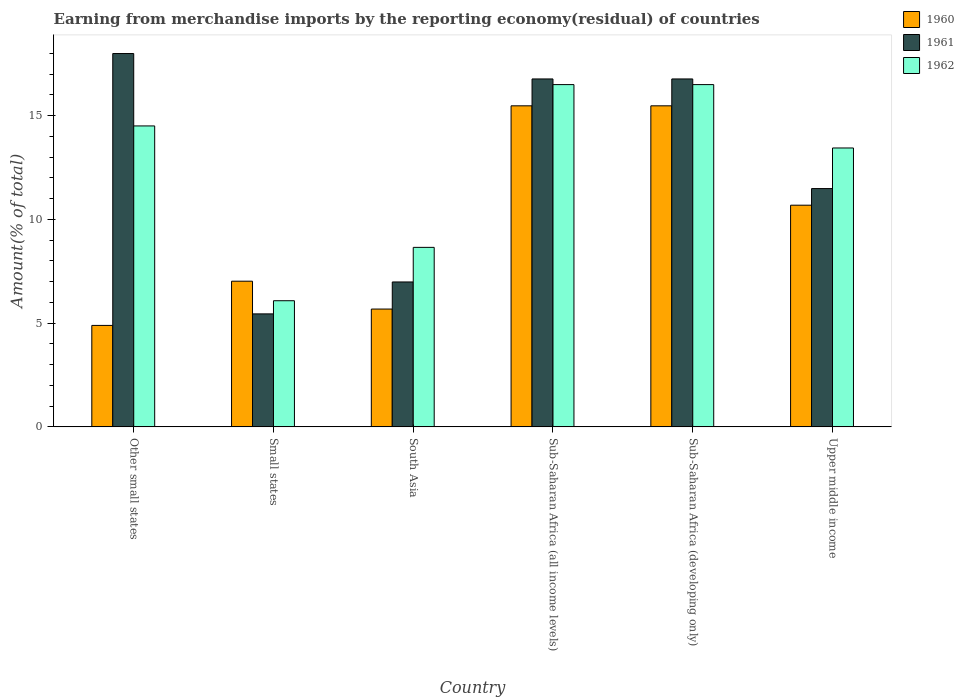How many different coloured bars are there?
Ensure brevity in your answer.  3. How many groups of bars are there?
Your answer should be very brief. 6. Are the number of bars per tick equal to the number of legend labels?
Give a very brief answer. Yes. Are the number of bars on each tick of the X-axis equal?
Your answer should be compact. Yes. What is the label of the 5th group of bars from the left?
Offer a terse response. Sub-Saharan Africa (developing only). In how many cases, is the number of bars for a given country not equal to the number of legend labels?
Give a very brief answer. 0. What is the percentage of amount earned from merchandise imports in 1960 in Other small states?
Offer a very short reply. 4.89. Across all countries, what is the maximum percentage of amount earned from merchandise imports in 1960?
Provide a short and direct response. 15.47. Across all countries, what is the minimum percentage of amount earned from merchandise imports in 1960?
Make the answer very short. 4.89. In which country was the percentage of amount earned from merchandise imports in 1960 maximum?
Keep it short and to the point. Sub-Saharan Africa (all income levels). In which country was the percentage of amount earned from merchandise imports in 1961 minimum?
Your answer should be compact. Small states. What is the total percentage of amount earned from merchandise imports in 1961 in the graph?
Provide a succinct answer. 75.45. What is the difference between the percentage of amount earned from merchandise imports in 1961 in South Asia and that in Upper middle income?
Your response must be concise. -4.5. What is the difference between the percentage of amount earned from merchandise imports in 1960 in Upper middle income and the percentage of amount earned from merchandise imports in 1962 in South Asia?
Offer a terse response. 2.03. What is the average percentage of amount earned from merchandise imports in 1961 per country?
Your answer should be very brief. 12.57. What is the difference between the percentage of amount earned from merchandise imports of/in 1960 and percentage of amount earned from merchandise imports of/in 1962 in Small states?
Make the answer very short. 0.94. In how many countries, is the percentage of amount earned from merchandise imports in 1961 greater than 6 %?
Keep it short and to the point. 5. What is the ratio of the percentage of amount earned from merchandise imports in 1960 in Other small states to that in South Asia?
Offer a very short reply. 0.86. Is the percentage of amount earned from merchandise imports in 1960 in South Asia less than that in Upper middle income?
Keep it short and to the point. Yes. Is the difference between the percentage of amount earned from merchandise imports in 1960 in Small states and Sub-Saharan Africa (developing only) greater than the difference between the percentage of amount earned from merchandise imports in 1962 in Small states and Sub-Saharan Africa (developing only)?
Make the answer very short. Yes. What is the difference between the highest and the second highest percentage of amount earned from merchandise imports in 1962?
Provide a succinct answer. 1.99. What is the difference between the highest and the lowest percentage of amount earned from merchandise imports in 1962?
Give a very brief answer. 10.42. In how many countries, is the percentage of amount earned from merchandise imports in 1960 greater than the average percentage of amount earned from merchandise imports in 1960 taken over all countries?
Keep it short and to the point. 3. What does the 2nd bar from the left in Other small states represents?
Give a very brief answer. 1961. What does the 3rd bar from the right in Other small states represents?
Ensure brevity in your answer.  1960. How many bars are there?
Offer a very short reply. 18. How many countries are there in the graph?
Your answer should be very brief. 6. Does the graph contain grids?
Provide a succinct answer. No. How are the legend labels stacked?
Your response must be concise. Vertical. What is the title of the graph?
Give a very brief answer. Earning from merchandise imports by the reporting economy(residual) of countries. Does "1979" appear as one of the legend labels in the graph?
Your response must be concise. No. What is the label or title of the X-axis?
Your answer should be compact. Country. What is the label or title of the Y-axis?
Make the answer very short. Amount(% of total). What is the Amount(% of total) in 1960 in Other small states?
Ensure brevity in your answer.  4.89. What is the Amount(% of total) of 1961 in Other small states?
Provide a short and direct response. 17.99. What is the Amount(% of total) of 1962 in Other small states?
Provide a short and direct response. 14.51. What is the Amount(% of total) in 1960 in Small states?
Offer a terse response. 7.02. What is the Amount(% of total) of 1961 in Small states?
Offer a very short reply. 5.45. What is the Amount(% of total) in 1962 in Small states?
Keep it short and to the point. 6.08. What is the Amount(% of total) in 1960 in South Asia?
Make the answer very short. 5.68. What is the Amount(% of total) of 1961 in South Asia?
Offer a terse response. 6.98. What is the Amount(% of total) in 1962 in South Asia?
Your answer should be compact. 8.65. What is the Amount(% of total) in 1960 in Sub-Saharan Africa (all income levels)?
Offer a very short reply. 15.47. What is the Amount(% of total) of 1961 in Sub-Saharan Africa (all income levels)?
Provide a succinct answer. 16.77. What is the Amount(% of total) in 1962 in Sub-Saharan Africa (all income levels)?
Provide a succinct answer. 16.5. What is the Amount(% of total) of 1960 in Sub-Saharan Africa (developing only)?
Offer a terse response. 15.47. What is the Amount(% of total) of 1961 in Sub-Saharan Africa (developing only)?
Keep it short and to the point. 16.77. What is the Amount(% of total) in 1962 in Sub-Saharan Africa (developing only)?
Your answer should be compact. 16.5. What is the Amount(% of total) in 1960 in Upper middle income?
Ensure brevity in your answer.  10.68. What is the Amount(% of total) of 1961 in Upper middle income?
Ensure brevity in your answer.  11.49. What is the Amount(% of total) of 1962 in Upper middle income?
Your response must be concise. 13.44. Across all countries, what is the maximum Amount(% of total) in 1960?
Make the answer very short. 15.47. Across all countries, what is the maximum Amount(% of total) in 1961?
Your answer should be compact. 17.99. Across all countries, what is the maximum Amount(% of total) of 1962?
Offer a terse response. 16.5. Across all countries, what is the minimum Amount(% of total) of 1960?
Provide a succinct answer. 4.89. Across all countries, what is the minimum Amount(% of total) in 1961?
Your answer should be compact. 5.45. Across all countries, what is the minimum Amount(% of total) of 1962?
Offer a very short reply. 6.08. What is the total Amount(% of total) in 1960 in the graph?
Ensure brevity in your answer.  59.22. What is the total Amount(% of total) of 1961 in the graph?
Your response must be concise. 75.45. What is the total Amount(% of total) of 1962 in the graph?
Make the answer very short. 75.67. What is the difference between the Amount(% of total) in 1960 in Other small states and that in Small states?
Offer a very short reply. -2.13. What is the difference between the Amount(% of total) of 1961 in Other small states and that in Small states?
Offer a terse response. 12.55. What is the difference between the Amount(% of total) in 1962 in Other small states and that in Small states?
Make the answer very short. 8.42. What is the difference between the Amount(% of total) in 1960 in Other small states and that in South Asia?
Keep it short and to the point. -0.79. What is the difference between the Amount(% of total) in 1961 in Other small states and that in South Asia?
Your answer should be very brief. 11.01. What is the difference between the Amount(% of total) of 1962 in Other small states and that in South Asia?
Offer a terse response. 5.85. What is the difference between the Amount(% of total) in 1960 in Other small states and that in Sub-Saharan Africa (all income levels)?
Your response must be concise. -10.58. What is the difference between the Amount(% of total) of 1961 in Other small states and that in Sub-Saharan Africa (all income levels)?
Ensure brevity in your answer.  1.22. What is the difference between the Amount(% of total) in 1962 in Other small states and that in Sub-Saharan Africa (all income levels)?
Offer a very short reply. -1.99. What is the difference between the Amount(% of total) of 1960 in Other small states and that in Sub-Saharan Africa (developing only)?
Provide a succinct answer. -10.58. What is the difference between the Amount(% of total) of 1961 in Other small states and that in Sub-Saharan Africa (developing only)?
Offer a terse response. 1.22. What is the difference between the Amount(% of total) in 1962 in Other small states and that in Sub-Saharan Africa (developing only)?
Offer a very short reply. -1.99. What is the difference between the Amount(% of total) in 1960 in Other small states and that in Upper middle income?
Make the answer very short. -5.79. What is the difference between the Amount(% of total) in 1961 in Other small states and that in Upper middle income?
Provide a short and direct response. 6.51. What is the difference between the Amount(% of total) of 1962 in Other small states and that in Upper middle income?
Provide a short and direct response. 1.06. What is the difference between the Amount(% of total) in 1960 in Small states and that in South Asia?
Provide a succinct answer. 1.34. What is the difference between the Amount(% of total) of 1961 in Small states and that in South Asia?
Your answer should be very brief. -1.54. What is the difference between the Amount(% of total) of 1962 in Small states and that in South Asia?
Your answer should be compact. -2.57. What is the difference between the Amount(% of total) in 1960 in Small states and that in Sub-Saharan Africa (all income levels)?
Ensure brevity in your answer.  -8.45. What is the difference between the Amount(% of total) of 1961 in Small states and that in Sub-Saharan Africa (all income levels)?
Your response must be concise. -11.32. What is the difference between the Amount(% of total) in 1962 in Small states and that in Sub-Saharan Africa (all income levels)?
Your response must be concise. -10.42. What is the difference between the Amount(% of total) in 1960 in Small states and that in Sub-Saharan Africa (developing only)?
Your answer should be very brief. -8.45. What is the difference between the Amount(% of total) of 1961 in Small states and that in Sub-Saharan Africa (developing only)?
Ensure brevity in your answer.  -11.32. What is the difference between the Amount(% of total) in 1962 in Small states and that in Sub-Saharan Africa (developing only)?
Give a very brief answer. -10.42. What is the difference between the Amount(% of total) of 1960 in Small states and that in Upper middle income?
Make the answer very short. -3.66. What is the difference between the Amount(% of total) in 1961 in Small states and that in Upper middle income?
Your answer should be very brief. -6.04. What is the difference between the Amount(% of total) in 1962 in Small states and that in Upper middle income?
Make the answer very short. -7.36. What is the difference between the Amount(% of total) in 1960 in South Asia and that in Sub-Saharan Africa (all income levels)?
Provide a short and direct response. -9.8. What is the difference between the Amount(% of total) in 1961 in South Asia and that in Sub-Saharan Africa (all income levels)?
Make the answer very short. -9.79. What is the difference between the Amount(% of total) in 1962 in South Asia and that in Sub-Saharan Africa (all income levels)?
Your answer should be very brief. -7.84. What is the difference between the Amount(% of total) of 1960 in South Asia and that in Sub-Saharan Africa (developing only)?
Your answer should be very brief. -9.8. What is the difference between the Amount(% of total) of 1961 in South Asia and that in Sub-Saharan Africa (developing only)?
Ensure brevity in your answer.  -9.79. What is the difference between the Amount(% of total) in 1962 in South Asia and that in Sub-Saharan Africa (developing only)?
Keep it short and to the point. -7.84. What is the difference between the Amount(% of total) of 1960 in South Asia and that in Upper middle income?
Ensure brevity in your answer.  -5.01. What is the difference between the Amount(% of total) in 1961 in South Asia and that in Upper middle income?
Provide a short and direct response. -4.5. What is the difference between the Amount(% of total) of 1962 in South Asia and that in Upper middle income?
Ensure brevity in your answer.  -4.79. What is the difference between the Amount(% of total) of 1961 in Sub-Saharan Africa (all income levels) and that in Sub-Saharan Africa (developing only)?
Provide a short and direct response. 0. What is the difference between the Amount(% of total) of 1962 in Sub-Saharan Africa (all income levels) and that in Sub-Saharan Africa (developing only)?
Give a very brief answer. 0. What is the difference between the Amount(% of total) in 1960 in Sub-Saharan Africa (all income levels) and that in Upper middle income?
Your response must be concise. 4.79. What is the difference between the Amount(% of total) in 1961 in Sub-Saharan Africa (all income levels) and that in Upper middle income?
Provide a short and direct response. 5.28. What is the difference between the Amount(% of total) of 1962 in Sub-Saharan Africa (all income levels) and that in Upper middle income?
Offer a very short reply. 3.05. What is the difference between the Amount(% of total) in 1960 in Sub-Saharan Africa (developing only) and that in Upper middle income?
Your answer should be compact. 4.79. What is the difference between the Amount(% of total) of 1961 in Sub-Saharan Africa (developing only) and that in Upper middle income?
Ensure brevity in your answer.  5.28. What is the difference between the Amount(% of total) of 1962 in Sub-Saharan Africa (developing only) and that in Upper middle income?
Make the answer very short. 3.05. What is the difference between the Amount(% of total) in 1960 in Other small states and the Amount(% of total) in 1961 in Small states?
Make the answer very short. -0.56. What is the difference between the Amount(% of total) in 1960 in Other small states and the Amount(% of total) in 1962 in Small states?
Give a very brief answer. -1.19. What is the difference between the Amount(% of total) of 1961 in Other small states and the Amount(% of total) of 1962 in Small states?
Keep it short and to the point. 11.91. What is the difference between the Amount(% of total) in 1960 in Other small states and the Amount(% of total) in 1961 in South Asia?
Your response must be concise. -2.09. What is the difference between the Amount(% of total) in 1960 in Other small states and the Amount(% of total) in 1962 in South Asia?
Your response must be concise. -3.76. What is the difference between the Amount(% of total) in 1961 in Other small states and the Amount(% of total) in 1962 in South Asia?
Offer a very short reply. 9.34. What is the difference between the Amount(% of total) of 1960 in Other small states and the Amount(% of total) of 1961 in Sub-Saharan Africa (all income levels)?
Your answer should be compact. -11.88. What is the difference between the Amount(% of total) in 1960 in Other small states and the Amount(% of total) in 1962 in Sub-Saharan Africa (all income levels)?
Provide a short and direct response. -11.61. What is the difference between the Amount(% of total) in 1961 in Other small states and the Amount(% of total) in 1962 in Sub-Saharan Africa (all income levels)?
Make the answer very short. 1.5. What is the difference between the Amount(% of total) in 1960 in Other small states and the Amount(% of total) in 1961 in Sub-Saharan Africa (developing only)?
Offer a terse response. -11.88. What is the difference between the Amount(% of total) of 1960 in Other small states and the Amount(% of total) of 1962 in Sub-Saharan Africa (developing only)?
Keep it short and to the point. -11.61. What is the difference between the Amount(% of total) in 1961 in Other small states and the Amount(% of total) in 1962 in Sub-Saharan Africa (developing only)?
Provide a succinct answer. 1.5. What is the difference between the Amount(% of total) of 1960 in Other small states and the Amount(% of total) of 1961 in Upper middle income?
Keep it short and to the point. -6.6. What is the difference between the Amount(% of total) of 1960 in Other small states and the Amount(% of total) of 1962 in Upper middle income?
Offer a terse response. -8.55. What is the difference between the Amount(% of total) of 1961 in Other small states and the Amount(% of total) of 1962 in Upper middle income?
Give a very brief answer. 4.55. What is the difference between the Amount(% of total) of 1960 in Small states and the Amount(% of total) of 1961 in South Asia?
Provide a succinct answer. 0.04. What is the difference between the Amount(% of total) of 1960 in Small states and the Amount(% of total) of 1962 in South Asia?
Provide a succinct answer. -1.63. What is the difference between the Amount(% of total) of 1961 in Small states and the Amount(% of total) of 1962 in South Asia?
Provide a succinct answer. -3.21. What is the difference between the Amount(% of total) in 1960 in Small states and the Amount(% of total) in 1961 in Sub-Saharan Africa (all income levels)?
Keep it short and to the point. -9.75. What is the difference between the Amount(% of total) in 1960 in Small states and the Amount(% of total) in 1962 in Sub-Saharan Africa (all income levels)?
Provide a succinct answer. -9.48. What is the difference between the Amount(% of total) of 1961 in Small states and the Amount(% of total) of 1962 in Sub-Saharan Africa (all income levels)?
Offer a very short reply. -11.05. What is the difference between the Amount(% of total) in 1960 in Small states and the Amount(% of total) in 1961 in Sub-Saharan Africa (developing only)?
Make the answer very short. -9.75. What is the difference between the Amount(% of total) in 1960 in Small states and the Amount(% of total) in 1962 in Sub-Saharan Africa (developing only)?
Your response must be concise. -9.48. What is the difference between the Amount(% of total) in 1961 in Small states and the Amount(% of total) in 1962 in Sub-Saharan Africa (developing only)?
Make the answer very short. -11.05. What is the difference between the Amount(% of total) in 1960 in Small states and the Amount(% of total) in 1961 in Upper middle income?
Offer a terse response. -4.46. What is the difference between the Amount(% of total) of 1960 in Small states and the Amount(% of total) of 1962 in Upper middle income?
Offer a very short reply. -6.42. What is the difference between the Amount(% of total) of 1961 in Small states and the Amount(% of total) of 1962 in Upper middle income?
Your answer should be very brief. -8. What is the difference between the Amount(% of total) in 1960 in South Asia and the Amount(% of total) in 1961 in Sub-Saharan Africa (all income levels)?
Make the answer very short. -11.09. What is the difference between the Amount(% of total) of 1960 in South Asia and the Amount(% of total) of 1962 in Sub-Saharan Africa (all income levels)?
Give a very brief answer. -10.82. What is the difference between the Amount(% of total) of 1961 in South Asia and the Amount(% of total) of 1962 in Sub-Saharan Africa (all income levels)?
Make the answer very short. -9.51. What is the difference between the Amount(% of total) in 1960 in South Asia and the Amount(% of total) in 1961 in Sub-Saharan Africa (developing only)?
Make the answer very short. -11.09. What is the difference between the Amount(% of total) in 1960 in South Asia and the Amount(% of total) in 1962 in Sub-Saharan Africa (developing only)?
Provide a succinct answer. -10.82. What is the difference between the Amount(% of total) of 1961 in South Asia and the Amount(% of total) of 1962 in Sub-Saharan Africa (developing only)?
Keep it short and to the point. -9.51. What is the difference between the Amount(% of total) of 1960 in South Asia and the Amount(% of total) of 1961 in Upper middle income?
Make the answer very short. -5.81. What is the difference between the Amount(% of total) in 1960 in South Asia and the Amount(% of total) in 1962 in Upper middle income?
Provide a succinct answer. -7.76. What is the difference between the Amount(% of total) in 1961 in South Asia and the Amount(% of total) in 1962 in Upper middle income?
Your answer should be compact. -6.46. What is the difference between the Amount(% of total) of 1960 in Sub-Saharan Africa (all income levels) and the Amount(% of total) of 1961 in Sub-Saharan Africa (developing only)?
Offer a very short reply. -1.3. What is the difference between the Amount(% of total) of 1960 in Sub-Saharan Africa (all income levels) and the Amount(% of total) of 1962 in Sub-Saharan Africa (developing only)?
Offer a very short reply. -1.02. What is the difference between the Amount(% of total) in 1961 in Sub-Saharan Africa (all income levels) and the Amount(% of total) in 1962 in Sub-Saharan Africa (developing only)?
Your answer should be compact. 0.27. What is the difference between the Amount(% of total) in 1960 in Sub-Saharan Africa (all income levels) and the Amount(% of total) in 1961 in Upper middle income?
Your answer should be compact. 3.99. What is the difference between the Amount(% of total) in 1960 in Sub-Saharan Africa (all income levels) and the Amount(% of total) in 1962 in Upper middle income?
Offer a very short reply. 2.03. What is the difference between the Amount(% of total) of 1961 in Sub-Saharan Africa (all income levels) and the Amount(% of total) of 1962 in Upper middle income?
Your answer should be compact. 3.33. What is the difference between the Amount(% of total) of 1960 in Sub-Saharan Africa (developing only) and the Amount(% of total) of 1961 in Upper middle income?
Your answer should be compact. 3.99. What is the difference between the Amount(% of total) in 1960 in Sub-Saharan Africa (developing only) and the Amount(% of total) in 1962 in Upper middle income?
Ensure brevity in your answer.  2.03. What is the difference between the Amount(% of total) in 1961 in Sub-Saharan Africa (developing only) and the Amount(% of total) in 1962 in Upper middle income?
Give a very brief answer. 3.33. What is the average Amount(% of total) of 1960 per country?
Ensure brevity in your answer.  9.87. What is the average Amount(% of total) in 1961 per country?
Your answer should be very brief. 12.57. What is the average Amount(% of total) in 1962 per country?
Ensure brevity in your answer.  12.61. What is the difference between the Amount(% of total) in 1960 and Amount(% of total) in 1961 in Other small states?
Provide a succinct answer. -13.1. What is the difference between the Amount(% of total) in 1960 and Amount(% of total) in 1962 in Other small states?
Keep it short and to the point. -9.62. What is the difference between the Amount(% of total) of 1961 and Amount(% of total) of 1962 in Other small states?
Make the answer very short. 3.49. What is the difference between the Amount(% of total) in 1960 and Amount(% of total) in 1961 in Small states?
Your response must be concise. 1.58. What is the difference between the Amount(% of total) in 1960 and Amount(% of total) in 1962 in Small states?
Offer a very short reply. 0.94. What is the difference between the Amount(% of total) of 1961 and Amount(% of total) of 1962 in Small states?
Offer a terse response. -0.63. What is the difference between the Amount(% of total) of 1960 and Amount(% of total) of 1961 in South Asia?
Keep it short and to the point. -1.31. What is the difference between the Amount(% of total) in 1960 and Amount(% of total) in 1962 in South Asia?
Provide a short and direct response. -2.97. What is the difference between the Amount(% of total) in 1961 and Amount(% of total) in 1962 in South Asia?
Your answer should be very brief. -1.67. What is the difference between the Amount(% of total) in 1960 and Amount(% of total) in 1961 in Sub-Saharan Africa (all income levels)?
Your answer should be compact. -1.3. What is the difference between the Amount(% of total) of 1960 and Amount(% of total) of 1962 in Sub-Saharan Africa (all income levels)?
Provide a succinct answer. -1.02. What is the difference between the Amount(% of total) in 1961 and Amount(% of total) in 1962 in Sub-Saharan Africa (all income levels)?
Provide a short and direct response. 0.27. What is the difference between the Amount(% of total) in 1960 and Amount(% of total) in 1961 in Sub-Saharan Africa (developing only)?
Ensure brevity in your answer.  -1.3. What is the difference between the Amount(% of total) of 1960 and Amount(% of total) of 1962 in Sub-Saharan Africa (developing only)?
Provide a succinct answer. -1.02. What is the difference between the Amount(% of total) of 1961 and Amount(% of total) of 1962 in Sub-Saharan Africa (developing only)?
Offer a very short reply. 0.27. What is the difference between the Amount(% of total) of 1960 and Amount(% of total) of 1961 in Upper middle income?
Offer a terse response. -0.8. What is the difference between the Amount(% of total) in 1960 and Amount(% of total) in 1962 in Upper middle income?
Provide a succinct answer. -2.76. What is the difference between the Amount(% of total) of 1961 and Amount(% of total) of 1962 in Upper middle income?
Offer a terse response. -1.96. What is the ratio of the Amount(% of total) in 1960 in Other small states to that in Small states?
Keep it short and to the point. 0.7. What is the ratio of the Amount(% of total) of 1961 in Other small states to that in Small states?
Ensure brevity in your answer.  3.3. What is the ratio of the Amount(% of total) in 1962 in Other small states to that in Small states?
Offer a very short reply. 2.39. What is the ratio of the Amount(% of total) of 1960 in Other small states to that in South Asia?
Make the answer very short. 0.86. What is the ratio of the Amount(% of total) in 1961 in Other small states to that in South Asia?
Offer a terse response. 2.58. What is the ratio of the Amount(% of total) of 1962 in Other small states to that in South Asia?
Provide a short and direct response. 1.68. What is the ratio of the Amount(% of total) in 1960 in Other small states to that in Sub-Saharan Africa (all income levels)?
Offer a terse response. 0.32. What is the ratio of the Amount(% of total) of 1961 in Other small states to that in Sub-Saharan Africa (all income levels)?
Ensure brevity in your answer.  1.07. What is the ratio of the Amount(% of total) in 1962 in Other small states to that in Sub-Saharan Africa (all income levels)?
Ensure brevity in your answer.  0.88. What is the ratio of the Amount(% of total) in 1960 in Other small states to that in Sub-Saharan Africa (developing only)?
Give a very brief answer. 0.32. What is the ratio of the Amount(% of total) of 1961 in Other small states to that in Sub-Saharan Africa (developing only)?
Ensure brevity in your answer.  1.07. What is the ratio of the Amount(% of total) in 1962 in Other small states to that in Sub-Saharan Africa (developing only)?
Your answer should be very brief. 0.88. What is the ratio of the Amount(% of total) in 1960 in Other small states to that in Upper middle income?
Keep it short and to the point. 0.46. What is the ratio of the Amount(% of total) in 1961 in Other small states to that in Upper middle income?
Ensure brevity in your answer.  1.57. What is the ratio of the Amount(% of total) in 1962 in Other small states to that in Upper middle income?
Offer a very short reply. 1.08. What is the ratio of the Amount(% of total) of 1960 in Small states to that in South Asia?
Your answer should be very brief. 1.24. What is the ratio of the Amount(% of total) in 1961 in Small states to that in South Asia?
Offer a terse response. 0.78. What is the ratio of the Amount(% of total) of 1962 in Small states to that in South Asia?
Keep it short and to the point. 0.7. What is the ratio of the Amount(% of total) of 1960 in Small states to that in Sub-Saharan Africa (all income levels)?
Make the answer very short. 0.45. What is the ratio of the Amount(% of total) of 1961 in Small states to that in Sub-Saharan Africa (all income levels)?
Ensure brevity in your answer.  0.32. What is the ratio of the Amount(% of total) in 1962 in Small states to that in Sub-Saharan Africa (all income levels)?
Your answer should be very brief. 0.37. What is the ratio of the Amount(% of total) in 1960 in Small states to that in Sub-Saharan Africa (developing only)?
Provide a short and direct response. 0.45. What is the ratio of the Amount(% of total) of 1961 in Small states to that in Sub-Saharan Africa (developing only)?
Keep it short and to the point. 0.32. What is the ratio of the Amount(% of total) of 1962 in Small states to that in Sub-Saharan Africa (developing only)?
Keep it short and to the point. 0.37. What is the ratio of the Amount(% of total) of 1960 in Small states to that in Upper middle income?
Ensure brevity in your answer.  0.66. What is the ratio of the Amount(% of total) in 1961 in Small states to that in Upper middle income?
Provide a short and direct response. 0.47. What is the ratio of the Amount(% of total) in 1962 in Small states to that in Upper middle income?
Your answer should be very brief. 0.45. What is the ratio of the Amount(% of total) of 1960 in South Asia to that in Sub-Saharan Africa (all income levels)?
Offer a very short reply. 0.37. What is the ratio of the Amount(% of total) of 1961 in South Asia to that in Sub-Saharan Africa (all income levels)?
Offer a terse response. 0.42. What is the ratio of the Amount(% of total) of 1962 in South Asia to that in Sub-Saharan Africa (all income levels)?
Give a very brief answer. 0.52. What is the ratio of the Amount(% of total) in 1960 in South Asia to that in Sub-Saharan Africa (developing only)?
Give a very brief answer. 0.37. What is the ratio of the Amount(% of total) of 1961 in South Asia to that in Sub-Saharan Africa (developing only)?
Offer a terse response. 0.42. What is the ratio of the Amount(% of total) of 1962 in South Asia to that in Sub-Saharan Africa (developing only)?
Your answer should be very brief. 0.52. What is the ratio of the Amount(% of total) in 1960 in South Asia to that in Upper middle income?
Your response must be concise. 0.53. What is the ratio of the Amount(% of total) in 1961 in South Asia to that in Upper middle income?
Provide a succinct answer. 0.61. What is the ratio of the Amount(% of total) of 1962 in South Asia to that in Upper middle income?
Ensure brevity in your answer.  0.64. What is the ratio of the Amount(% of total) in 1960 in Sub-Saharan Africa (all income levels) to that in Sub-Saharan Africa (developing only)?
Your answer should be very brief. 1. What is the ratio of the Amount(% of total) of 1961 in Sub-Saharan Africa (all income levels) to that in Sub-Saharan Africa (developing only)?
Your answer should be compact. 1. What is the ratio of the Amount(% of total) of 1962 in Sub-Saharan Africa (all income levels) to that in Sub-Saharan Africa (developing only)?
Make the answer very short. 1. What is the ratio of the Amount(% of total) in 1960 in Sub-Saharan Africa (all income levels) to that in Upper middle income?
Your response must be concise. 1.45. What is the ratio of the Amount(% of total) in 1961 in Sub-Saharan Africa (all income levels) to that in Upper middle income?
Ensure brevity in your answer.  1.46. What is the ratio of the Amount(% of total) of 1962 in Sub-Saharan Africa (all income levels) to that in Upper middle income?
Your answer should be compact. 1.23. What is the ratio of the Amount(% of total) in 1960 in Sub-Saharan Africa (developing only) to that in Upper middle income?
Give a very brief answer. 1.45. What is the ratio of the Amount(% of total) in 1961 in Sub-Saharan Africa (developing only) to that in Upper middle income?
Offer a very short reply. 1.46. What is the ratio of the Amount(% of total) of 1962 in Sub-Saharan Africa (developing only) to that in Upper middle income?
Your answer should be compact. 1.23. What is the difference between the highest and the second highest Amount(% of total) of 1961?
Your answer should be compact. 1.22. What is the difference between the highest and the second highest Amount(% of total) of 1962?
Provide a succinct answer. 0. What is the difference between the highest and the lowest Amount(% of total) of 1960?
Provide a short and direct response. 10.58. What is the difference between the highest and the lowest Amount(% of total) in 1961?
Offer a very short reply. 12.55. What is the difference between the highest and the lowest Amount(% of total) in 1962?
Give a very brief answer. 10.42. 